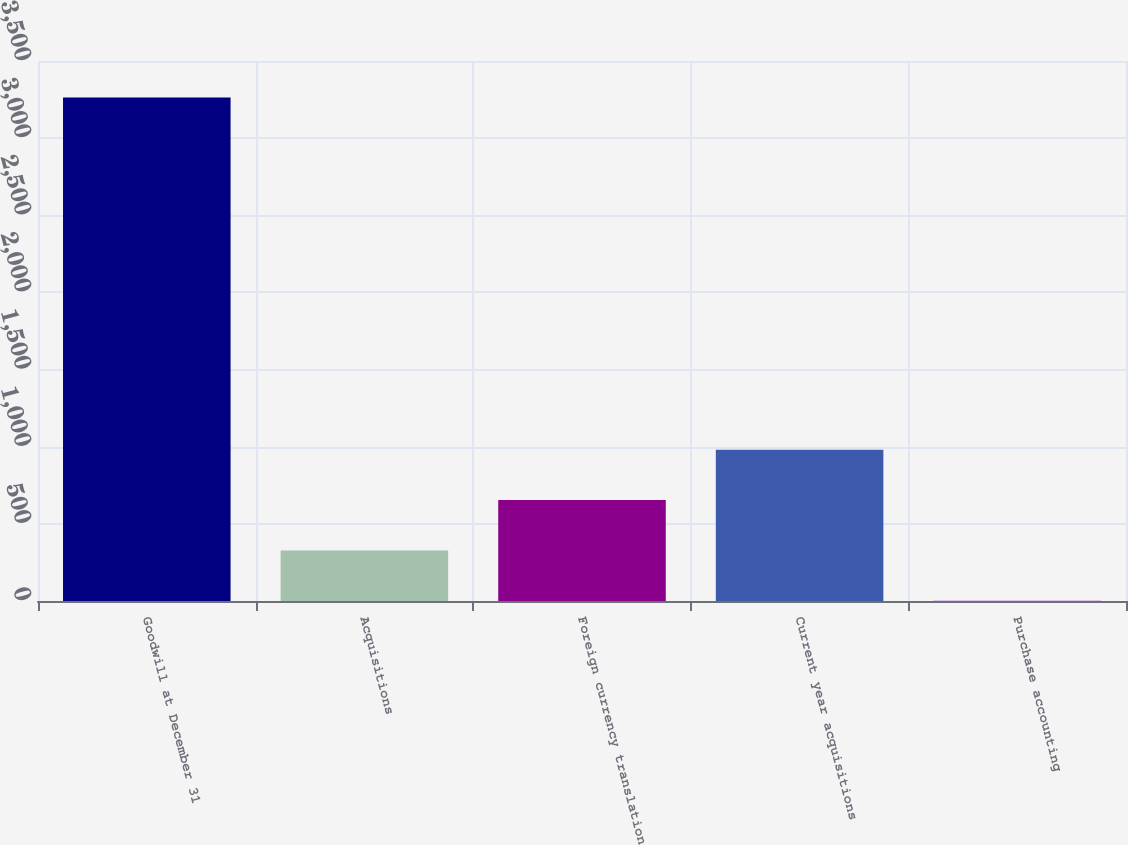Convert chart. <chart><loc_0><loc_0><loc_500><loc_500><bar_chart><fcel>Goodwill at December 31<fcel>Acquisitions<fcel>Foreign currency translation<fcel>Current year acquisitions<fcel>Purchase accounting<nl><fcel>3264.2<fcel>327.86<fcel>654.12<fcel>980.38<fcel>1.6<nl></chart> 